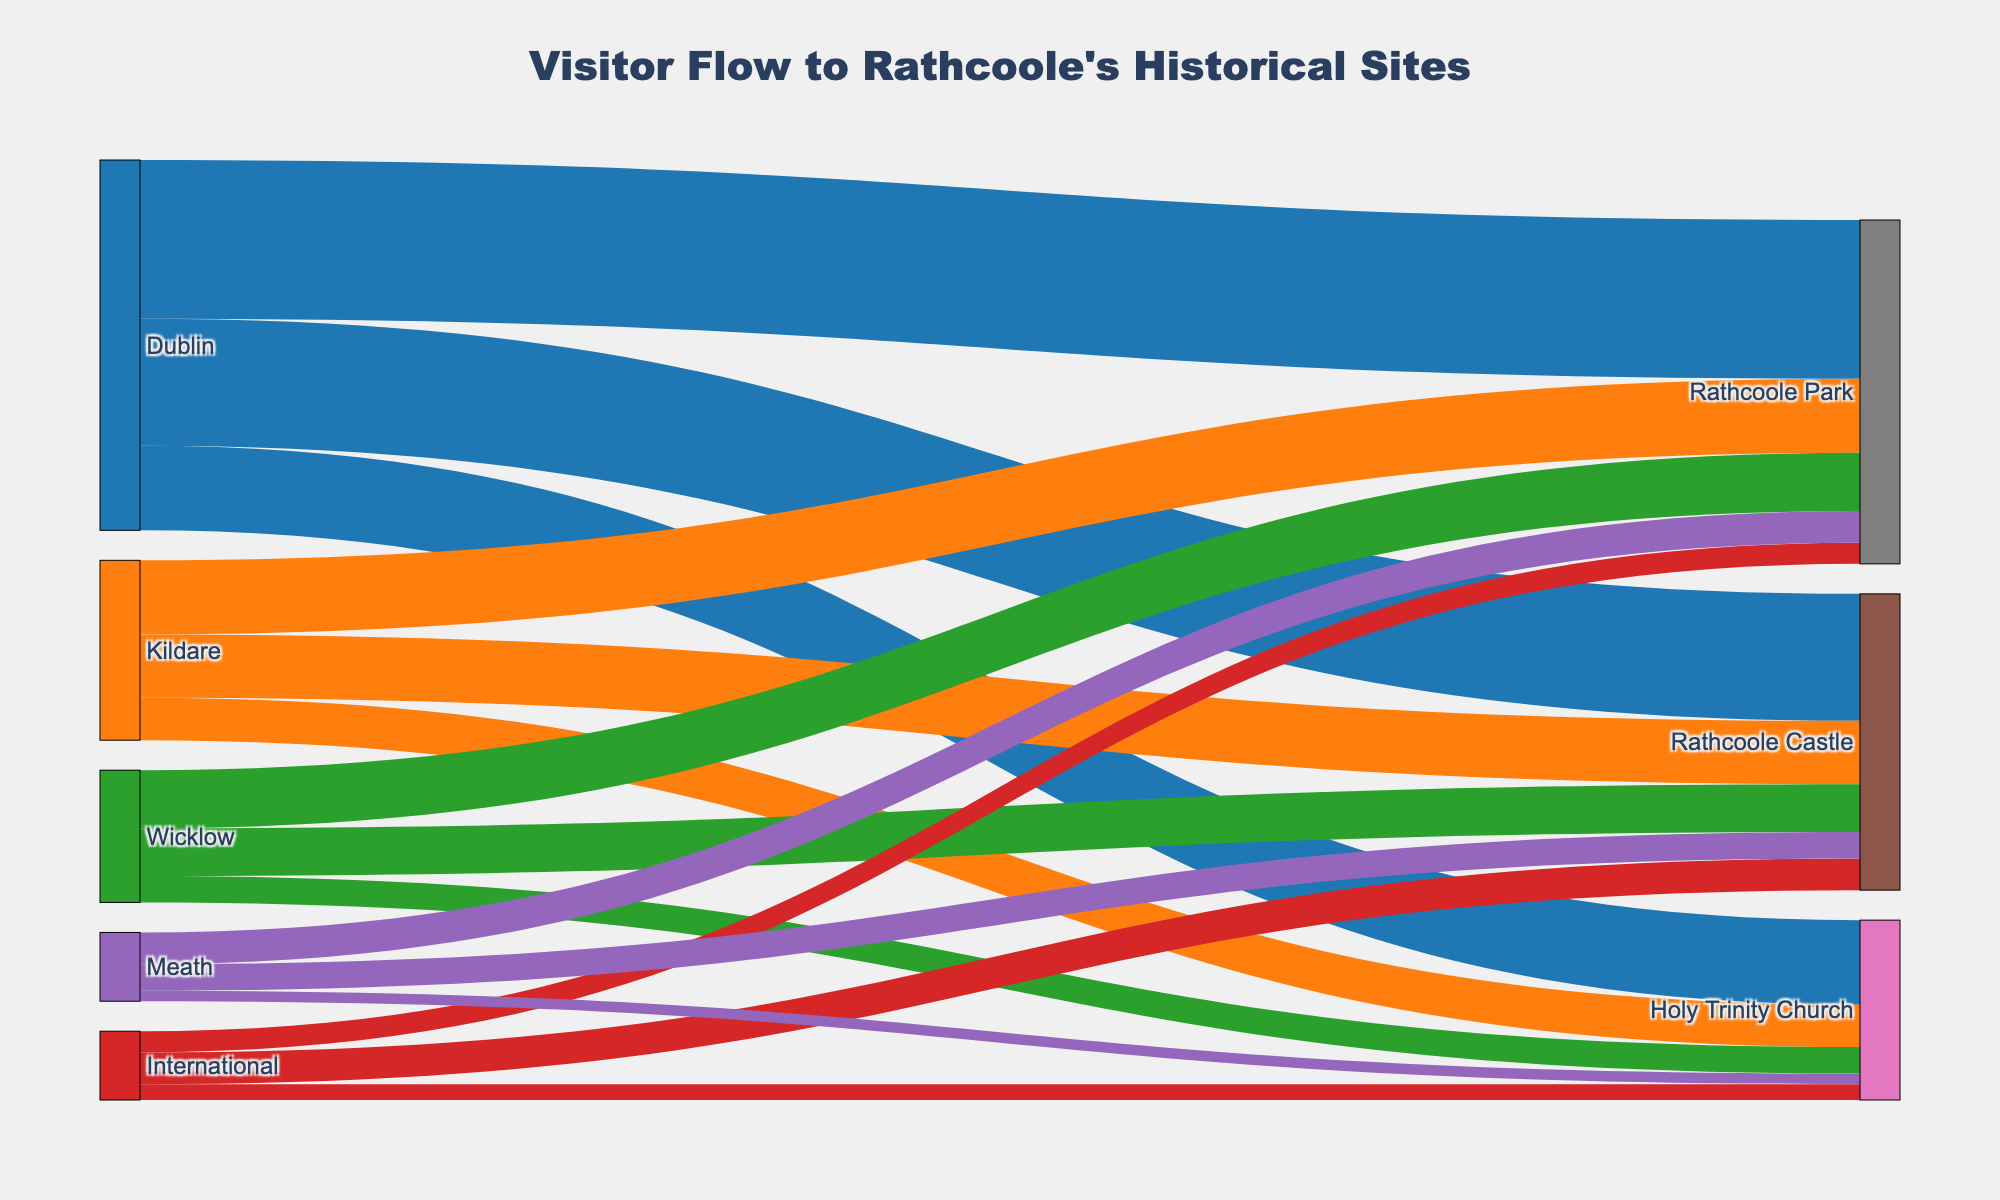How many visitor origins are represented in the Sankey diagram? The diagram includes each unique visitor origin. The origins listed are Dublin, Kildare, Wicklow, International, and Meath, making it a total of 5.
Answer: 5 Which attraction in Rathcoole received the highest number of visitors from Dublin? Look at the links originating from Dublin and see which one has the largest value. Rathcoole Park has 1500 visitors, which is the highest from Dublin.
Answer: Rathcoole Park What is the total number of visitors to Rathcoole Castle? Sum the number of visitors to Rathcoole Castle from all origins. (1200 from Dublin, 600 from Kildare, 450 from Wicklow, 300 from International, and 250 from Meath) = 2800.
Answer: 2800 Which visitor origin contributed the least number of visitors to Holy Trinity Church? Compare the number of visitors to Holy Trinity Church from all origins. Meath has the least with 100 visitors.
Answer: Meath What is the combined number of visitors from Wicklow to all attractions? Sum the number of visitors from Wicklow to each attraction. 450 (Rathcoole Castle) + 250 (Holy Trinity Church) + 550 (Rathcoole Park) = 1250.
Answer: 1250 How does the number of visitors from Kildare to Rathcoole Castle compare to the number of visitors from International to Rathcoole Castle? Compare the two numbers directly. Kildare contributed 600 visitors, and International contributed 300 visitors to Rathcoole Castle. 600 is more than 300.
Answer: Kildare has more Which attraction has the lowest overall number of visitors? Sum the visitors for each individual attraction across all origins and compare. Holy Trinity Church receives a total of 1700 (800 from Dublin, 400 from Kildare, 250 from Wicklow, 150 from International, and 100 from Meath). Rathcoole Castle has 2800, and Rathcoole Park has 3250 in total.
Answer: Holy Trinity Church What is the total number of visitors from Dublin to all attractions? Sum the number of visitors from Dublin to each attraction. 1200 (Rathcoole Castle) + 800 (Holy Trinity Church) + 1500 (Rathcoole Park) = 3500.
Answer: 3500 How does the number of visitors from Meath to Rathcoole Park compare to the number of visitors from International to Rathcoole Castle? Compare the two numbers directly. Meath has 300 visitors to Rathcoole Park, and International has 300 visitors to Rathcoole Castle. Both numbers are equal.
Answer: Equal 